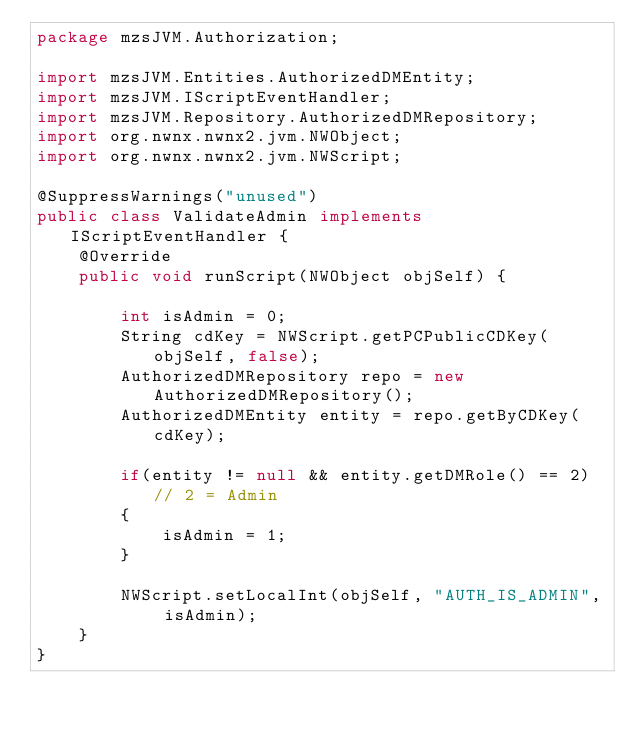Convert code to text. <code><loc_0><loc_0><loc_500><loc_500><_Java_>package mzsJVM.Authorization;

import mzsJVM.Entities.AuthorizedDMEntity;
import mzsJVM.IScriptEventHandler;
import mzsJVM.Repository.AuthorizedDMRepository;
import org.nwnx.nwnx2.jvm.NWObject;
import org.nwnx.nwnx2.jvm.NWScript;

@SuppressWarnings("unused")
public class ValidateAdmin implements IScriptEventHandler {
    @Override
    public void runScript(NWObject objSelf) {

        int isAdmin = 0;
        String cdKey = NWScript.getPCPublicCDKey(objSelf, false);
        AuthorizedDMRepository repo = new AuthorizedDMRepository();
        AuthorizedDMEntity entity = repo.getByCDKey(cdKey);

        if(entity != null && entity.getDMRole() == 2) // 2 = Admin
        {
            isAdmin = 1;
        }

        NWScript.setLocalInt(objSelf, "AUTH_IS_ADMIN", isAdmin);
    }
}
</code> 